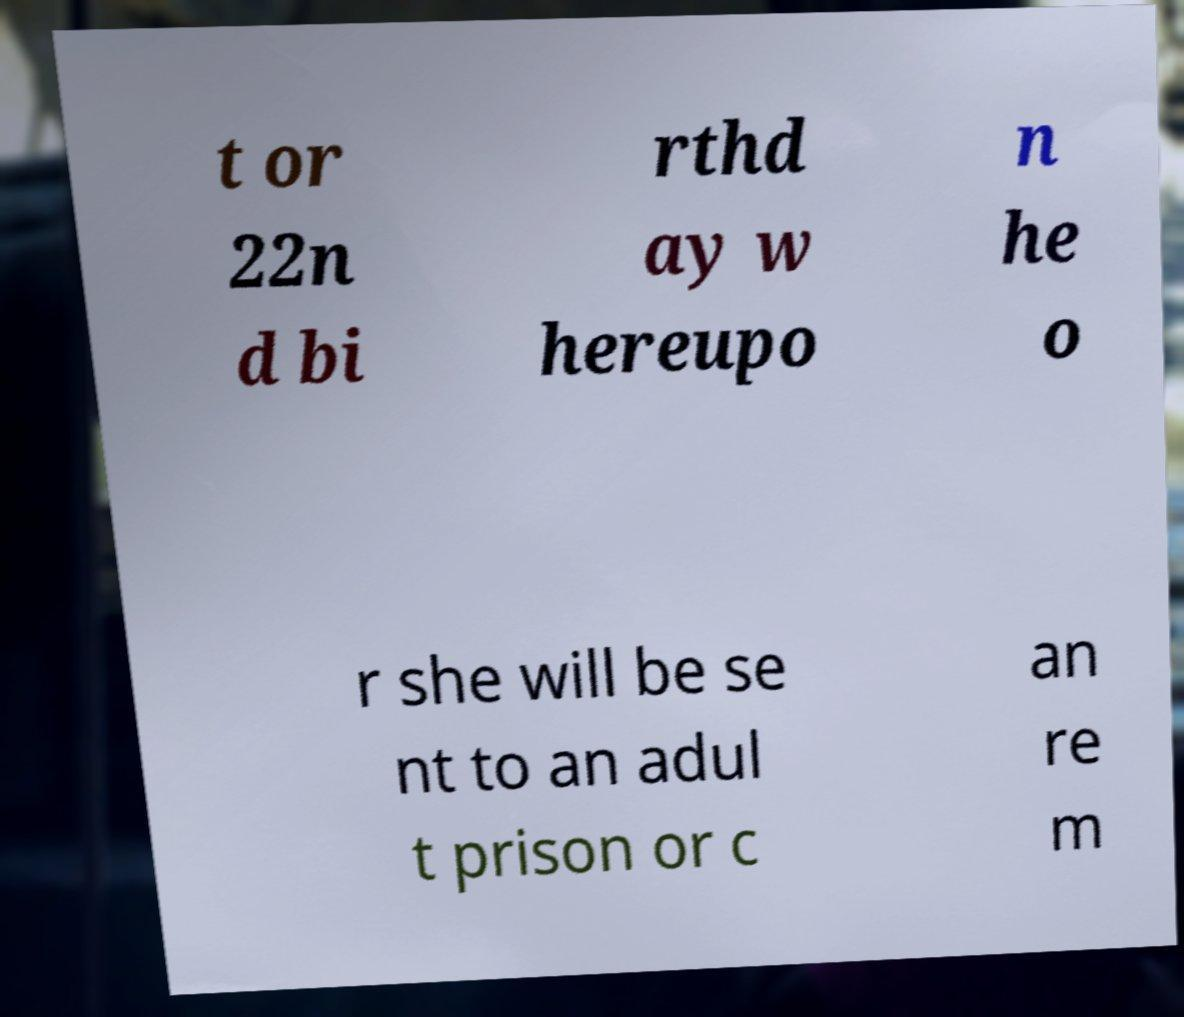Can you read and provide the text displayed in the image?This photo seems to have some interesting text. Can you extract and type it out for me? t or 22n d bi rthd ay w hereupo n he o r she will be se nt to an adul t prison or c an re m 